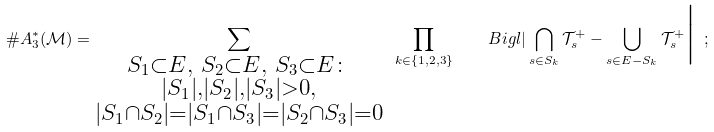<formula> <loc_0><loc_0><loc_500><loc_500>\# A _ { 3 } ^ { \ast } ( \mathcal { M } ) = \sum _ { \substack { S _ { 1 } \subset E , \ S _ { 2 } \subset E , \ S _ { 3 } \subset E \colon \\ | S _ { 1 } | , | S _ { 2 } | , | S _ { 3 } | > 0 , \\ | S _ { 1 } \cap S _ { 2 } | = | S _ { 1 } \cap S _ { 3 } | = | S _ { 2 } \cap S _ { 3 } | = 0 } } \ \prod _ { k \in \{ 1 , 2 , 3 \} } \quad B i g l | \bigcap _ { s \in S _ { k } } \mathcal { T } _ { s } ^ { + } - \bigcup _ { s \in E - S _ { k } } \mathcal { T } _ { s } ^ { + } \Big | \ ;</formula> 